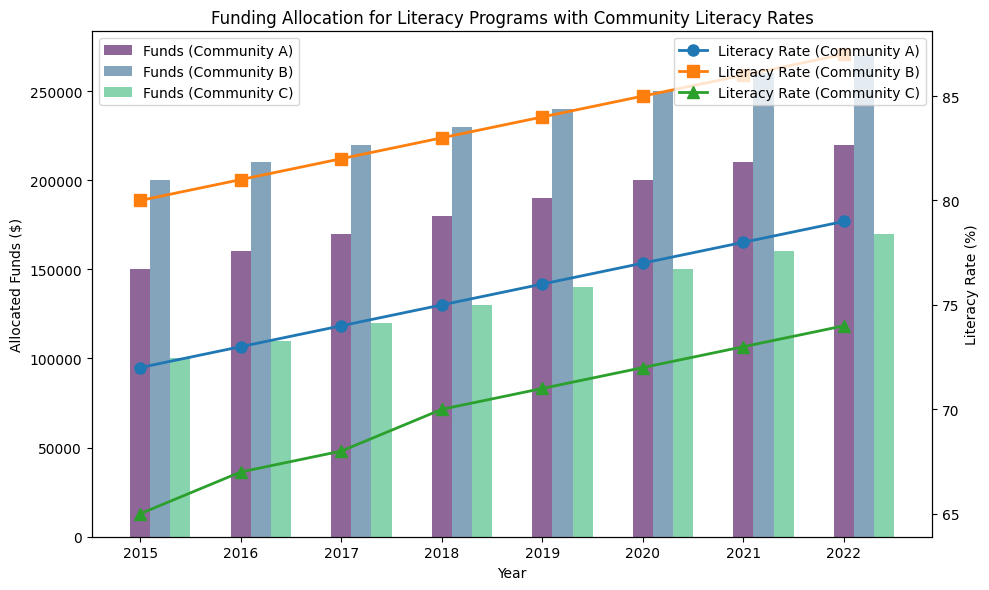What was the trend in allocated funds for Community A from 2015 to 2022? The allocated funds for Community A increased each year from 2015 to 2022. By examining the bar heights for Community A, we see a consistent upward trend from $150,000 in 2015 to $220,000 in 2022.
Answer: Increasing Which community had the highest literacy rate in 2022? By looking at the line markers for 2022, Community B had the highest literacy rate at 87%.
Answer: Community B How much more funding was allocated to Community B compared to Community C in 2018? In 2018, the heights of the bars for Community B and Community C show $230,000 and $130,000 respectively. The difference is $230,000 - $130,000 = $100,000.
Answer: $100,000 What was the average literacy rate for Community C over the entire period? The literacy rates for Community C from 2015 to 2022 are 65%, 67%, 68%, 70%, 71%, 72%, 73%, and 74%. Sum these values: 65 + 67 + 68 + 70 + 71 + 72 + 73 + 74 = 560. The average is 560/8 = 70.
Answer: 70% Did any community have a decrease in allocated funds in any year? Examining the bar heights for each community, none of the communities show any decreases in allocated funds in any given year.
Answer: No Comparing 2017, which community saw the greatest increase in literacy rate relative to 2016? Community A increased from 73% to 74% (+1%), Community B from 81% to 82% (+1%), and Community C from 67% to 68% (+1%). All communities had a similar increase of 1%.
Answer: None (All equal) In which year did Community B’s literacy rate surpass 80% for the first time? Referring to the line markers, Community B’s literacy rate was first above 80% in 2016, with a rate of 81%.
Answer: 2016 What’s the difference in literacy rates between Community A and Community C in 2022? In 2022, Community A had a literacy rate of 79%, and Community C had 74%. The difference is 79% - 74% = 5%.
Answer: 5% What was the total allocated funds for all communities combined in 2020? Adding the bar heights for all communities in 2020: $200,000 (A) + $250,000 (B) + $150,000 (C) = $600,000.
Answer: $600,000 